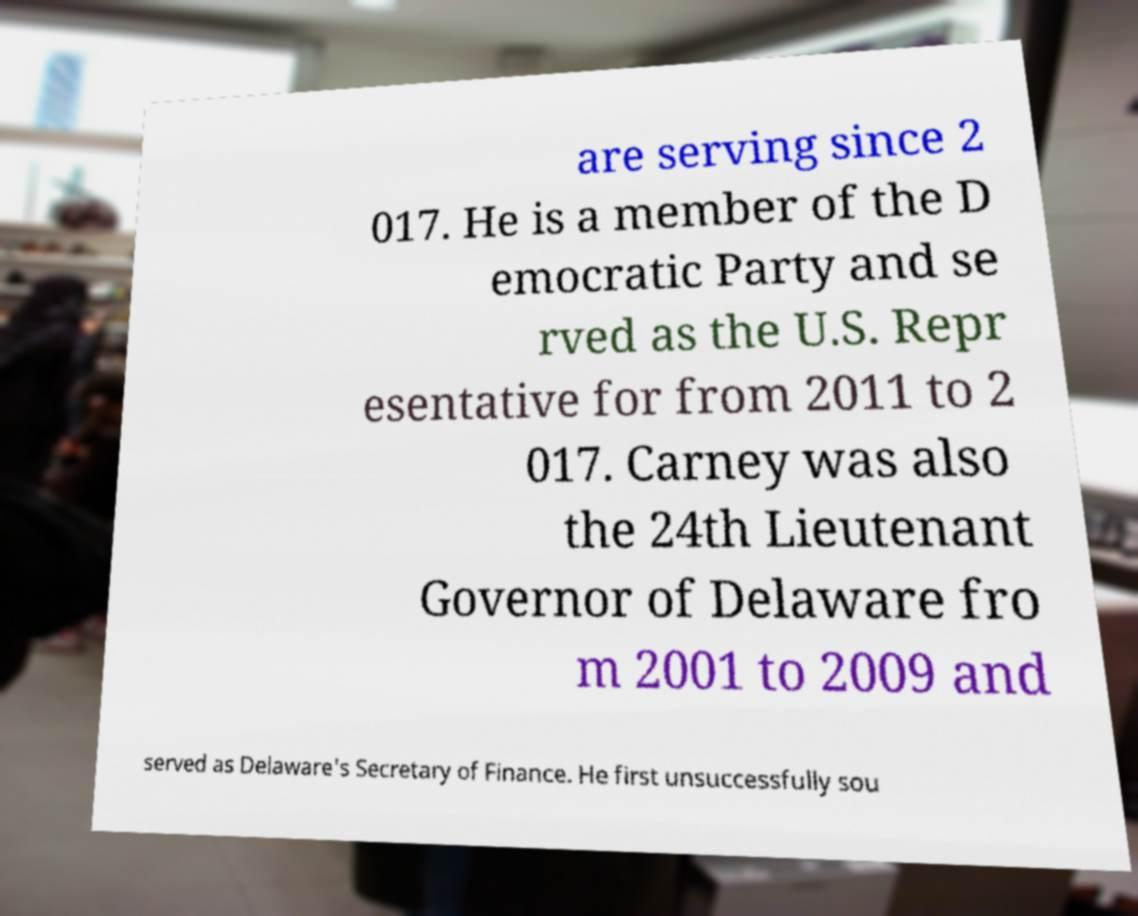Please identify and transcribe the text found in this image. are serving since 2 017. He is a member of the D emocratic Party and se rved as the U.S. Repr esentative for from 2011 to 2 017. Carney was also the 24th Lieutenant Governor of Delaware fro m 2001 to 2009 and served as Delaware's Secretary of Finance. He first unsuccessfully sou 